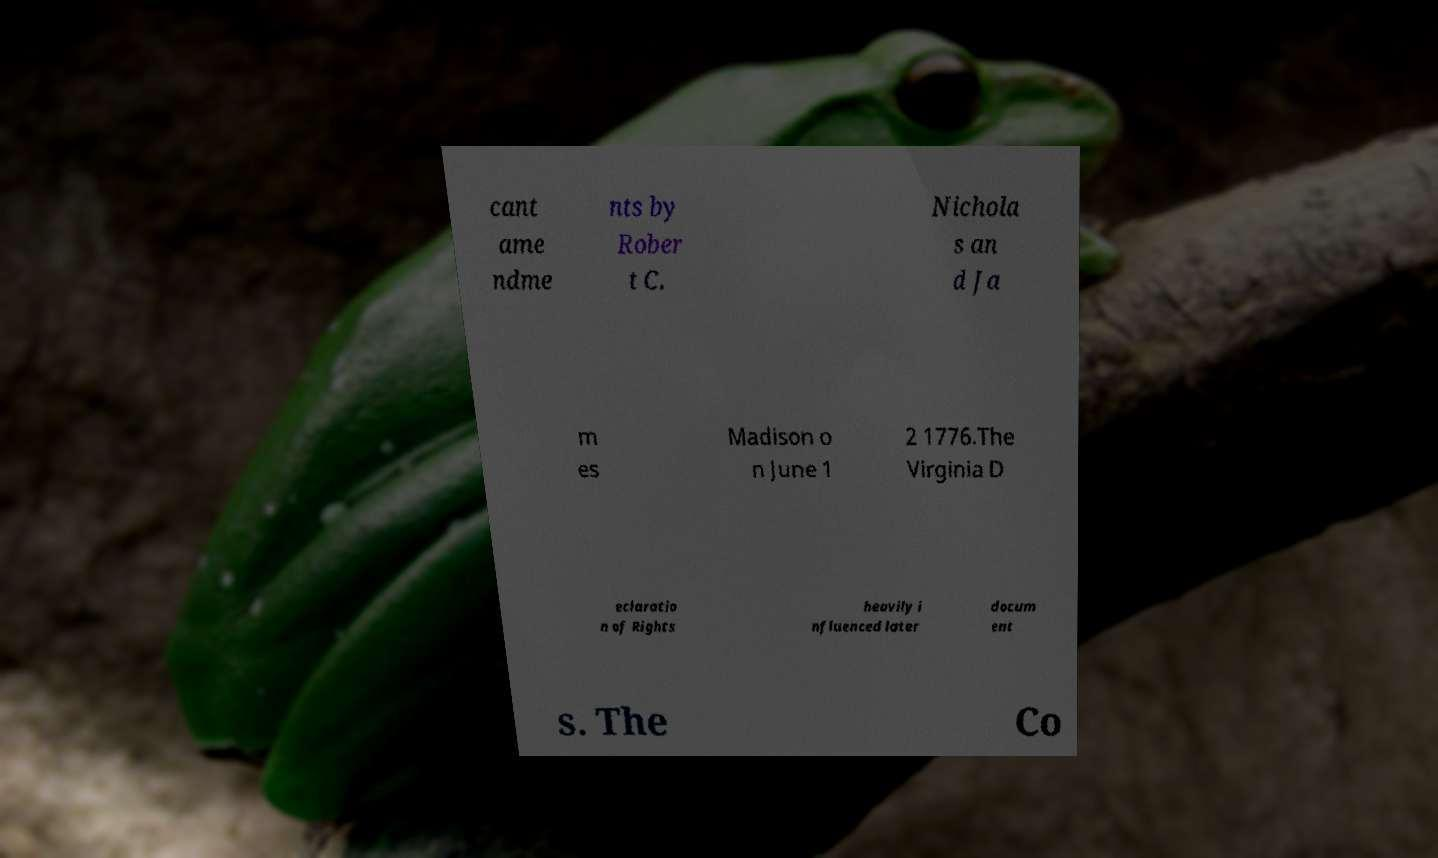Can you accurately transcribe the text from the provided image for me? cant ame ndme nts by Rober t C. Nichola s an d Ja m es Madison o n June 1 2 1776.The Virginia D eclaratio n of Rights heavily i nfluenced later docum ent s. The Co 